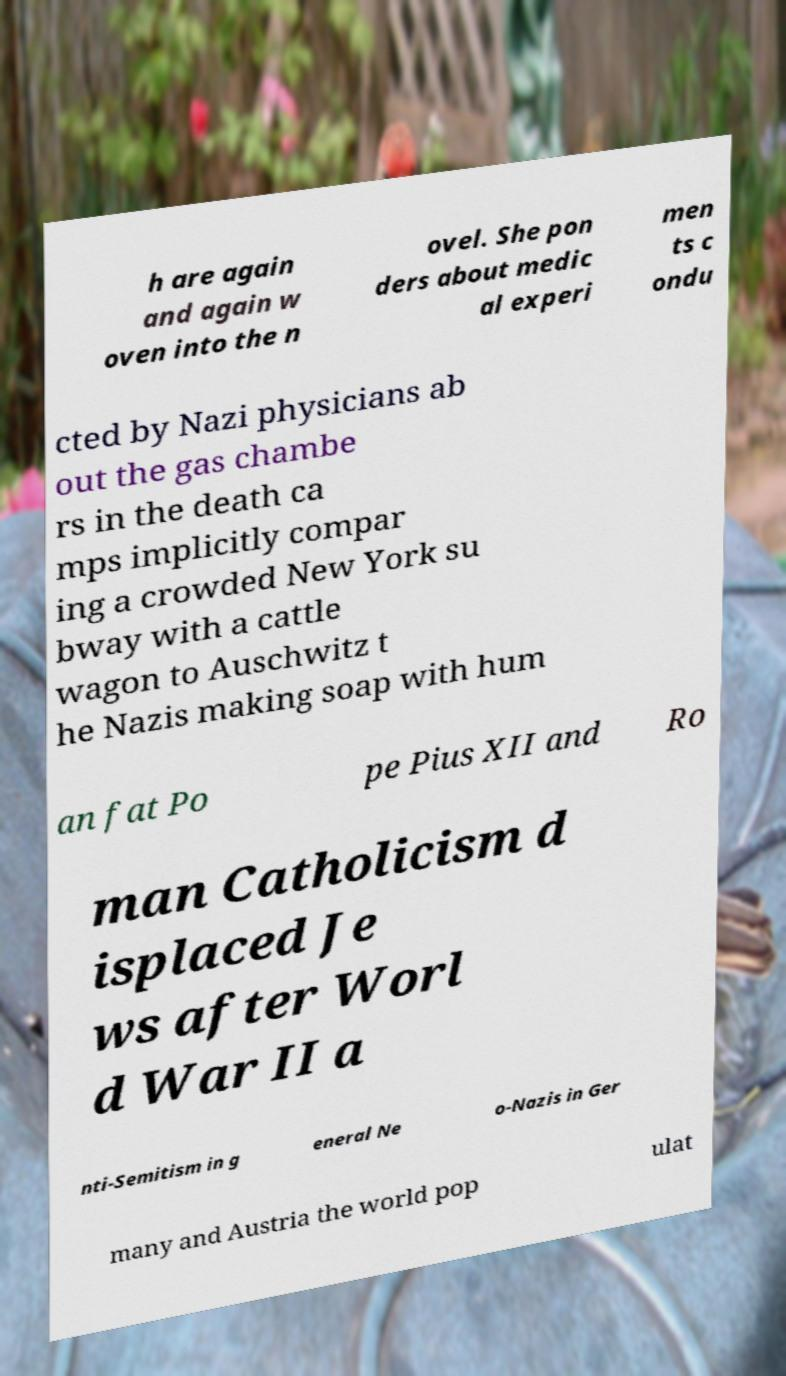Could you assist in decoding the text presented in this image and type it out clearly? h are again and again w oven into the n ovel. She pon ders about medic al experi men ts c ondu cted by Nazi physicians ab out the gas chambe rs in the death ca mps implicitly compar ing a crowded New York su bway with a cattle wagon to Auschwitz t he Nazis making soap with hum an fat Po pe Pius XII and Ro man Catholicism d isplaced Je ws after Worl d War II a nti-Semitism in g eneral Ne o-Nazis in Ger many and Austria the world pop ulat 